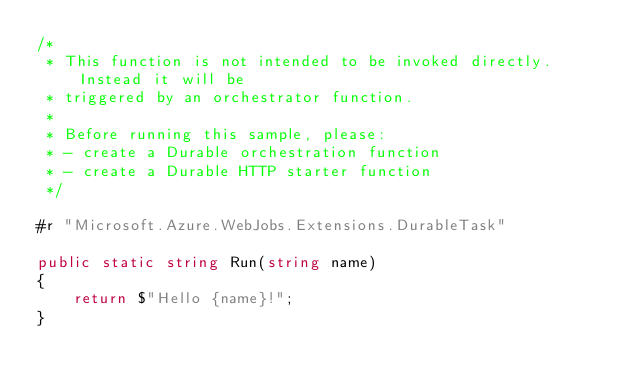Convert code to text. <code><loc_0><loc_0><loc_500><loc_500><_C#_>/*
 * This function is not intended to be invoked directly. Instead it will be
 * triggered by an orchestrator function.
 * 
 * Before running this sample, please:
 * - create a Durable orchestration function
 * - create a Durable HTTP starter function
 */

#r "Microsoft.Azure.WebJobs.Extensions.DurableTask"

public static string Run(string name)
{
    return $"Hello {name}!";
}</code> 